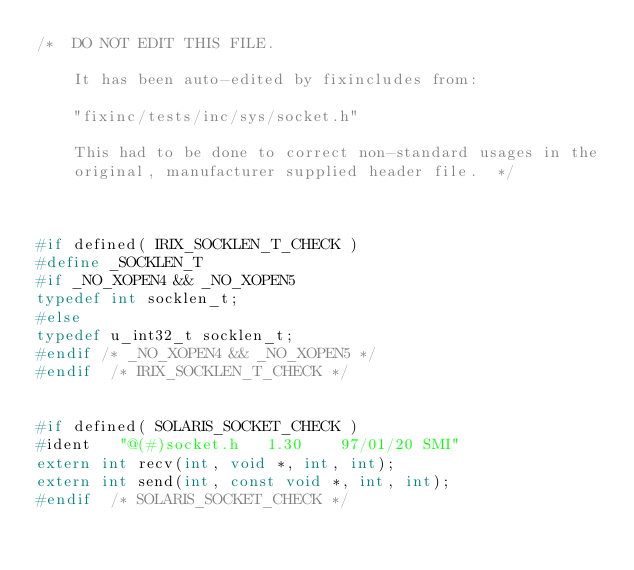Convert code to text. <code><loc_0><loc_0><loc_500><loc_500><_C_>/*  DO NOT EDIT THIS FILE.

    It has been auto-edited by fixincludes from:

	"fixinc/tests/inc/sys/socket.h"

    This had to be done to correct non-standard usages in the
    original, manufacturer supplied header file.  */



#if defined( IRIX_SOCKLEN_T_CHECK )
#define _SOCKLEN_T
#if _NO_XOPEN4 && _NO_XOPEN5
typedef int socklen_t;
#else
typedef u_int32_t socklen_t;
#endif /* _NO_XOPEN4 && _NO_XOPEN5 */
#endif  /* IRIX_SOCKLEN_T_CHECK */


#if defined( SOLARIS_SOCKET_CHECK )
#ident   "@(#)socket.h   1.30    97/01/20 SMI"
extern int recv(int, void *, int, int);
extern int send(int, const void *, int, int);
#endif  /* SOLARIS_SOCKET_CHECK */
</code> 